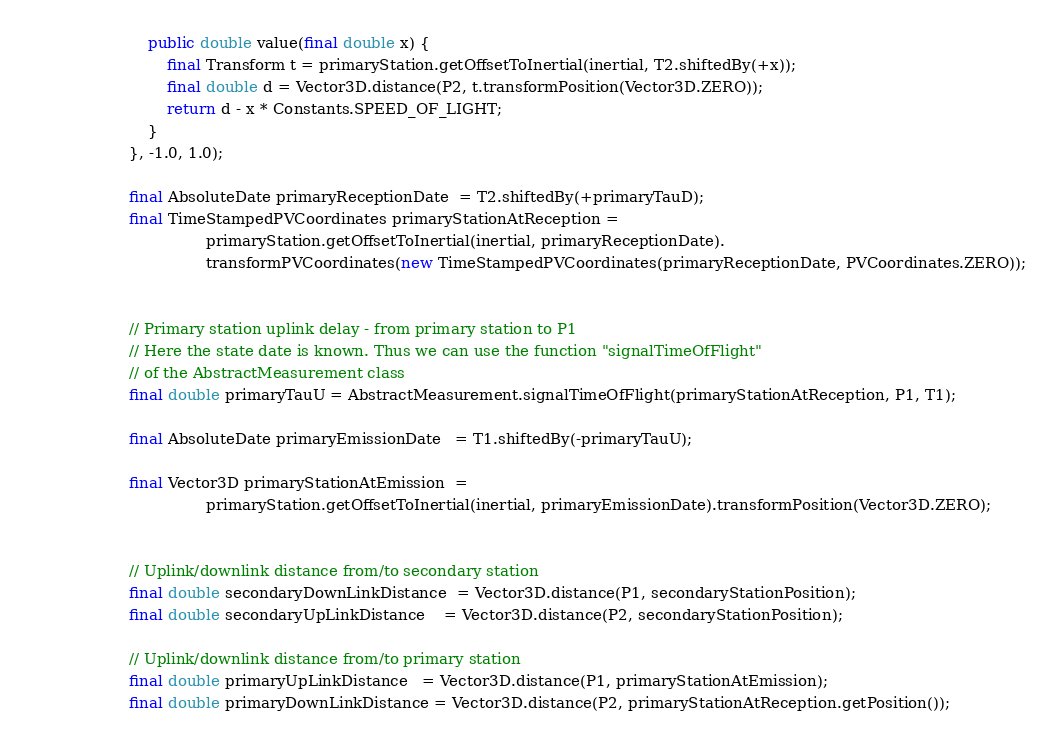<code> <loc_0><loc_0><loc_500><loc_500><_Java_>                        public double value(final double x) {
                            final Transform t = primaryStation.getOffsetToInertial(inertial, T2.shiftedBy(+x));
                            final double d = Vector3D.distance(P2, t.transformPosition(Vector3D.ZERO));
                            return d - x * Constants.SPEED_OF_LIGHT;
                        }
                    }, -1.0, 1.0);

                    final AbsoluteDate primaryReceptionDate  = T2.shiftedBy(+primaryTauD);
                    final TimeStampedPVCoordinates primaryStationAtReception =
                                    primaryStation.getOffsetToInertial(inertial, primaryReceptionDate).
                                    transformPVCoordinates(new TimeStampedPVCoordinates(primaryReceptionDate, PVCoordinates.ZERO));


                    // Primary station uplink delay - from primary station to P1
                    // Here the state date is known. Thus we can use the function "signalTimeOfFlight"
                    // of the AbstractMeasurement class
                    final double primaryTauU = AbstractMeasurement.signalTimeOfFlight(primaryStationAtReception, P1, T1);

                    final AbsoluteDate primaryEmissionDate   = T1.shiftedBy(-primaryTauU);

                    final Vector3D primaryStationAtEmission  =
                                    primaryStation.getOffsetToInertial(inertial, primaryEmissionDate).transformPosition(Vector3D.ZERO);


                    // Uplink/downlink distance from/to secondary station
                    final double secondaryDownLinkDistance  = Vector3D.distance(P1, secondaryStationPosition);
                    final double secondaryUpLinkDistance    = Vector3D.distance(P2, secondaryStationPosition);

                    // Uplink/downlink distance from/to primary station
                    final double primaryUpLinkDistance   = Vector3D.distance(P1, primaryStationAtEmission);
                    final double primaryDownLinkDistance = Vector3D.distance(P2, primaryStationAtReception.getPosition());
</code> 